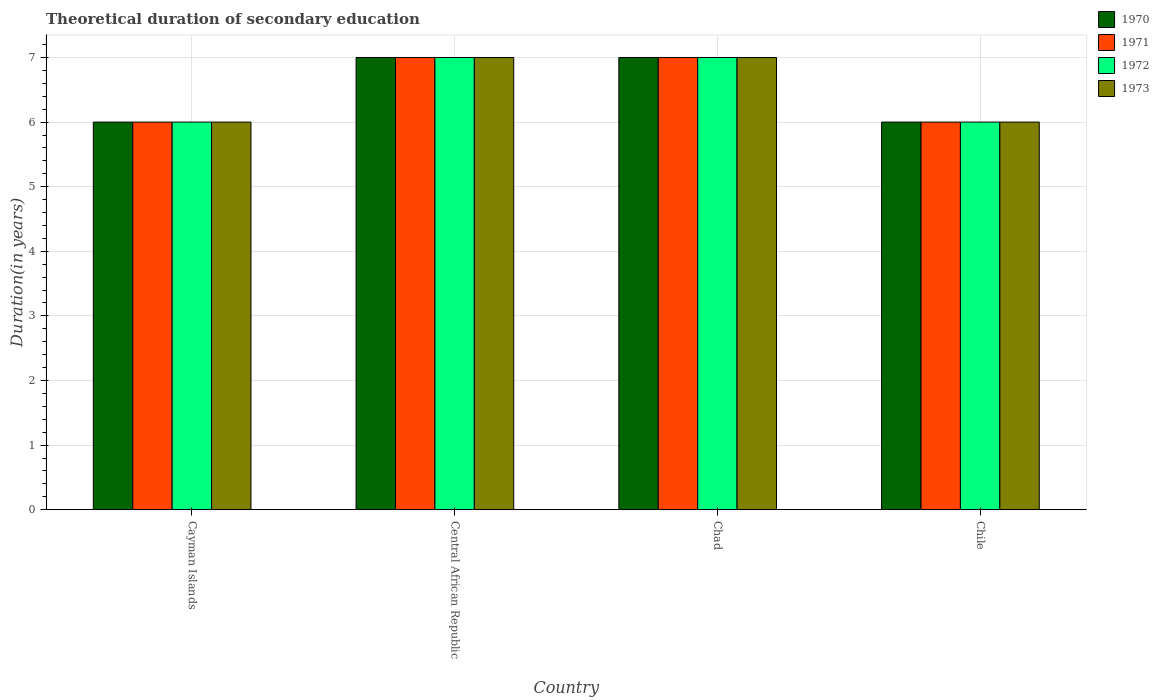How many groups of bars are there?
Your answer should be compact. 4. How many bars are there on the 2nd tick from the right?
Provide a succinct answer. 4. What is the label of the 1st group of bars from the left?
Your response must be concise. Cayman Islands. Across all countries, what is the maximum total theoretical duration of secondary education in 1971?
Your response must be concise. 7. In which country was the total theoretical duration of secondary education in 1972 maximum?
Make the answer very short. Central African Republic. In which country was the total theoretical duration of secondary education in 1972 minimum?
Provide a succinct answer. Cayman Islands. What is the average total theoretical duration of secondary education in 1972 per country?
Provide a short and direct response. 6.5. What is the difference between the total theoretical duration of secondary education of/in 1972 and total theoretical duration of secondary education of/in 1970 in Cayman Islands?
Give a very brief answer. 0. What is the ratio of the total theoretical duration of secondary education in 1970 in Cayman Islands to that in Chad?
Provide a succinct answer. 0.86. What is the difference between the highest and the second highest total theoretical duration of secondary education in 1972?
Offer a very short reply. -1. What is the difference between the highest and the lowest total theoretical duration of secondary education in 1973?
Your answer should be compact. 1. In how many countries, is the total theoretical duration of secondary education in 1973 greater than the average total theoretical duration of secondary education in 1973 taken over all countries?
Provide a succinct answer. 2. Is the sum of the total theoretical duration of secondary education in 1971 in Cayman Islands and Central African Republic greater than the maximum total theoretical duration of secondary education in 1972 across all countries?
Offer a terse response. Yes. Is it the case that in every country, the sum of the total theoretical duration of secondary education in 1971 and total theoretical duration of secondary education in 1972 is greater than the sum of total theoretical duration of secondary education in 1970 and total theoretical duration of secondary education in 1973?
Provide a succinct answer. No. What does the 4th bar from the left in Chad represents?
Provide a short and direct response. 1973. What does the 3rd bar from the right in Central African Republic represents?
Your response must be concise. 1971. Does the graph contain any zero values?
Your response must be concise. No. What is the title of the graph?
Make the answer very short. Theoretical duration of secondary education. What is the label or title of the Y-axis?
Your answer should be very brief. Duration(in years). What is the Duration(in years) of 1971 in Cayman Islands?
Offer a very short reply. 6. What is the Duration(in years) of 1970 in Central African Republic?
Offer a terse response. 7. What is the Duration(in years) of 1973 in Central African Republic?
Make the answer very short. 7. What is the Duration(in years) of 1972 in Chad?
Provide a short and direct response. 7. What is the Duration(in years) in 1973 in Chad?
Provide a short and direct response. 7. What is the Duration(in years) in 1970 in Chile?
Give a very brief answer. 6. What is the Duration(in years) in 1972 in Chile?
Ensure brevity in your answer.  6. What is the Duration(in years) in 1973 in Chile?
Provide a succinct answer. 6. Across all countries, what is the maximum Duration(in years) of 1970?
Provide a short and direct response. 7. Across all countries, what is the maximum Duration(in years) of 1972?
Offer a terse response. 7. Across all countries, what is the minimum Duration(in years) in 1971?
Give a very brief answer. 6. Across all countries, what is the minimum Duration(in years) in 1972?
Provide a short and direct response. 6. What is the total Duration(in years) in 1971 in the graph?
Ensure brevity in your answer.  26. What is the total Duration(in years) in 1972 in the graph?
Give a very brief answer. 26. What is the difference between the Duration(in years) in 1972 in Cayman Islands and that in Central African Republic?
Offer a terse response. -1. What is the difference between the Duration(in years) of 1973 in Cayman Islands and that in Central African Republic?
Offer a terse response. -1. What is the difference between the Duration(in years) in 1973 in Cayman Islands and that in Chad?
Give a very brief answer. -1. What is the difference between the Duration(in years) in 1972 in Cayman Islands and that in Chile?
Offer a very short reply. 0. What is the difference between the Duration(in years) in 1970 in Central African Republic and that in Chad?
Provide a short and direct response. 0. What is the difference between the Duration(in years) in 1971 in Central African Republic and that in Chad?
Make the answer very short. 0. What is the difference between the Duration(in years) in 1972 in Central African Republic and that in Chad?
Make the answer very short. 0. What is the difference between the Duration(in years) in 1973 in Central African Republic and that in Chad?
Offer a very short reply. 0. What is the difference between the Duration(in years) in 1972 in Central African Republic and that in Chile?
Give a very brief answer. 1. What is the difference between the Duration(in years) in 1973 in Central African Republic and that in Chile?
Your response must be concise. 1. What is the difference between the Duration(in years) of 1970 in Chad and that in Chile?
Keep it short and to the point. 1. What is the difference between the Duration(in years) of 1970 in Cayman Islands and the Duration(in years) of 1973 in Central African Republic?
Your answer should be compact. -1. What is the difference between the Duration(in years) in 1972 in Cayman Islands and the Duration(in years) in 1973 in Central African Republic?
Your answer should be compact. -1. What is the difference between the Duration(in years) in 1970 in Cayman Islands and the Duration(in years) in 1971 in Chad?
Provide a succinct answer. -1. What is the difference between the Duration(in years) in 1970 in Cayman Islands and the Duration(in years) in 1972 in Chad?
Offer a terse response. -1. What is the difference between the Duration(in years) of 1971 in Cayman Islands and the Duration(in years) of 1973 in Chad?
Your response must be concise. -1. What is the difference between the Duration(in years) of 1972 in Cayman Islands and the Duration(in years) of 1973 in Chad?
Offer a terse response. -1. What is the difference between the Duration(in years) in 1970 in Cayman Islands and the Duration(in years) in 1973 in Chile?
Your response must be concise. 0. What is the difference between the Duration(in years) in 1971 in Cayman Islands and the Duration(in years) in 1973 in Chile?
Make the answer very short. 0. What is the difference between the Duration(in years) in 1970 in Central African Republic and the Duration(in years) in 1973 in Chad?
Provide a short and direct response. 0. What is the difference between the Duration(in years) of 1971 in Central African Republic and the Duration(in years) of 1972 in Chad?
Offer a terse response. 0. What is the difference between the Duration(in years) in 1971 in Central African Republic and the Duration(in years) in 1973 in Chad?
Offer a terse response. 0. What is the difference between the Duration(in years) of 1972 in Central African Republic and the Duration(in years) of 1973 in Chad?
Your response must be concise. 0. What is the difference between the Duration(in years) of 1970 in Central African Republic and the Duration(in years) of 1972 in Chile?
Offer a very short reply. 1. What is the difference between the Duration(in years) of 1970 in Central African Republic and the Duration(in years) of 1973 in Chile?
Give a very brief answer. 1. What is the difference between the Duration(in years) of 1971 in Central African Republic and the Duration(in years) of 1973 in Chile?
Give a very brief answer. 1. What is the difference between the Duration(in years) of 1970 in Chad and the Duration(in years) of 1972 in Chile?
Give a very brief answer. 1. What is the difference between the Duration(in years) of 1970 in Chad and the Duration(in years) of 1973 in Chile?
Offer a very short reply. 1. What is the difference between the Duration(in years) of 1971 in Chad and the Duration(in years) of 1972 in Chile?
Your answer should be compact. 1. What is the difference between the Duration(in years) in 1971 in Chad and the Duration(in years) in 1973 in Chile?
Your answer should be very brief. 1. What is the average Duration(in years) of 1972 per country?
Your response must be concise. 6.5. What is the average Duration(in years) of 1973 per country?
Give a very brief answer. 6.5. What is the difference between the Duration(in years) in 1970 and Duration(in years) in 1971 in Cayman Islands?
Offer a terse response. 0. What is the difference between the Duration(in years) of 1970 and Duration(in years) of 1973 in Cayman Islands?
Offer a very short reply. 0. What is the difference between the Duration(in years) in 1971 and Duration(in years) in 1972 in Cayman Islands?
Ensure brevity in your answer.  0. What is the difference between the Duration(in years) of 1971 and Duration(in years) of 1973 in Cayman Islands?
Make the answer very short. 0. What is the difference between the Duration(in years) of 1972 and Duration(in years) of 1973 in Cayman Islands?
Offer a terse response. 0. What is the difference between the Duration(in years) of 1970 and Duration(in years) of 1971 in Central African Republic?
Make the answer very short. 0. What is the difference between the Duration(in years) in 1971 and Duration(in years) in 1973 in Central African Republic?
Your response must be concise. 0. What is the difference between the Duration(in years) in 1972 and Duration(in years) in 1973 in Central African Republic?
Give a very brief answer. 0. What is the difference between the Duration(in years) of 1970 and Duration(in years) of 1973 in Chad?
Your answer should be compact. 0. What is the difference between the Duration(in years) of 1970 and Duration(in years) of 1971 in Chile?
Offer a very short reply. 0. What is the difference between the Duration(in years) in 1970 and Duration(in years) in 1973 in Chile?
Ensure brevity in your answer.  0. What is the difference between the Duration(in years) of 1972 and Duration(in years) of 1973 in Chile?
Give a very brief answer. 0. What is the ratio of the Duration(in years) of 1970 in Cayman Islands to that in Central African Republic?
Your response must be concise. 0.86. What is the ratio of the Duration(in years) of 1973 in Cayman Islands to that in Chad?
Keep it short and to the point. 0.86. What is the ratio of the Duration(in years) in 1972 in Cayman Islands to that in Chile?
Give a very brief answer. 1. What is the ratio of the Duration(in years) in 1970 in Central African Republic to that in Chad?
Give a very brief answer. 1. What is the ratio of the Duration(in years) of 1972 in Central African Republic to that in Chad?
Ensure brevity in your answer.  1. What is the ratio of the Duration(in years) of 1971 in Central African Republic to that in Chile?
Your answer should be compact. 1.17. What is the ratio of the Duration(in years) in 1972 in Central African Republic to that in Chile?
Ensure brevity in your answer.  1.17. What is the ratio of the Duration(in years) in 1970 in Chad to that in Chile?
Give a very brief answer. 1.17. What is the ratio of the Duration(in years) in 1973 in Chad to that in Chile?
Offer a terse response. 1.17. What is the difference between the highest and the second highest Duration(in years) of 1970?
Offer a very short reply. 0. What is the difference between the highest and the second highest Duration(in years) of 1973?
Give a very brief answer. 0. What is the difference between the highest and the lowest Duration(in years) in 1970?
Ensure brevity in your answer.  1. What is the difference between the highest and the lowest Duration(in years) of 1971?
Give a very brief answer. 1. 